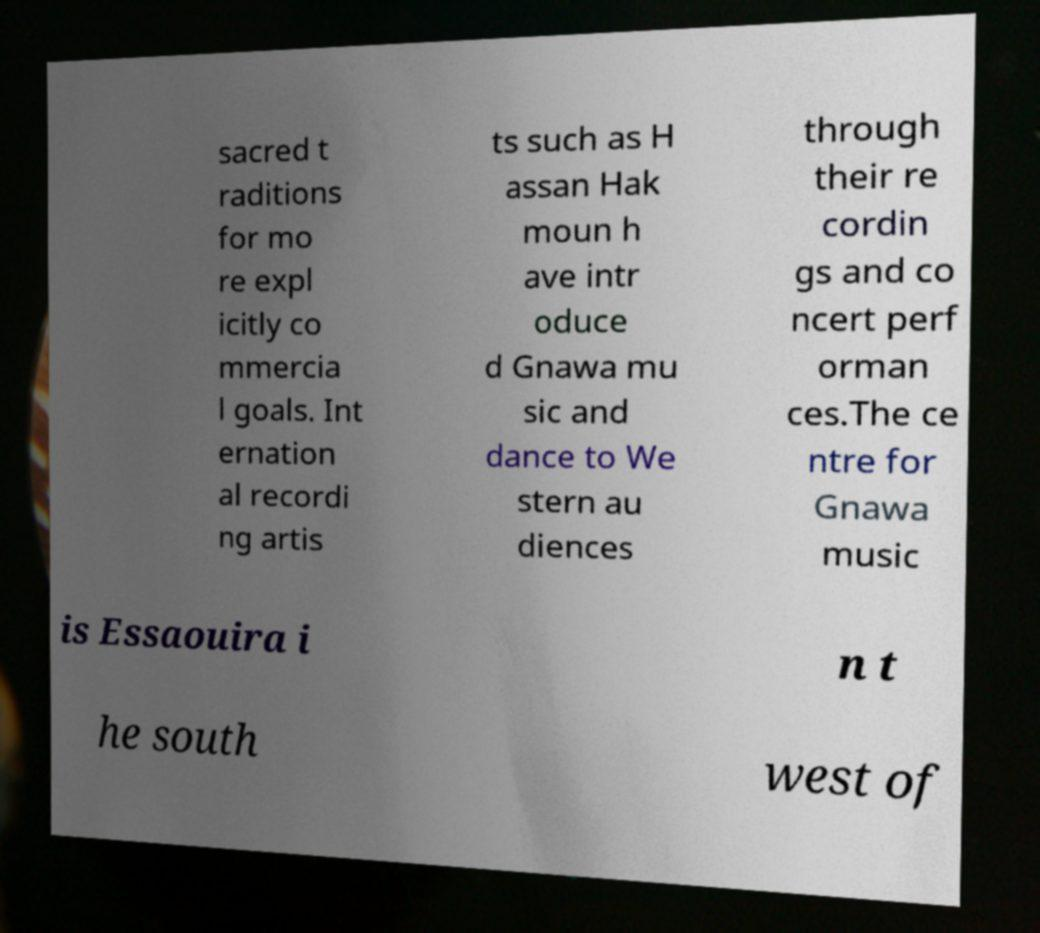Can you read and provide the text displayed in the image?This photo seems to have some interesting text. Can you extract and type it out for me? sacred t raditions for mo re expl icitly co mmercia l goals. Int ernation al recordi ng artis ts such as H assan Hak moun h ave intr oduce d Gnawa mu sic and dance to We stern au diences through their re cordin gs and co ncert perf orman ces.The ce ntre for Gnawa music is Essaouira i n t he south west of 